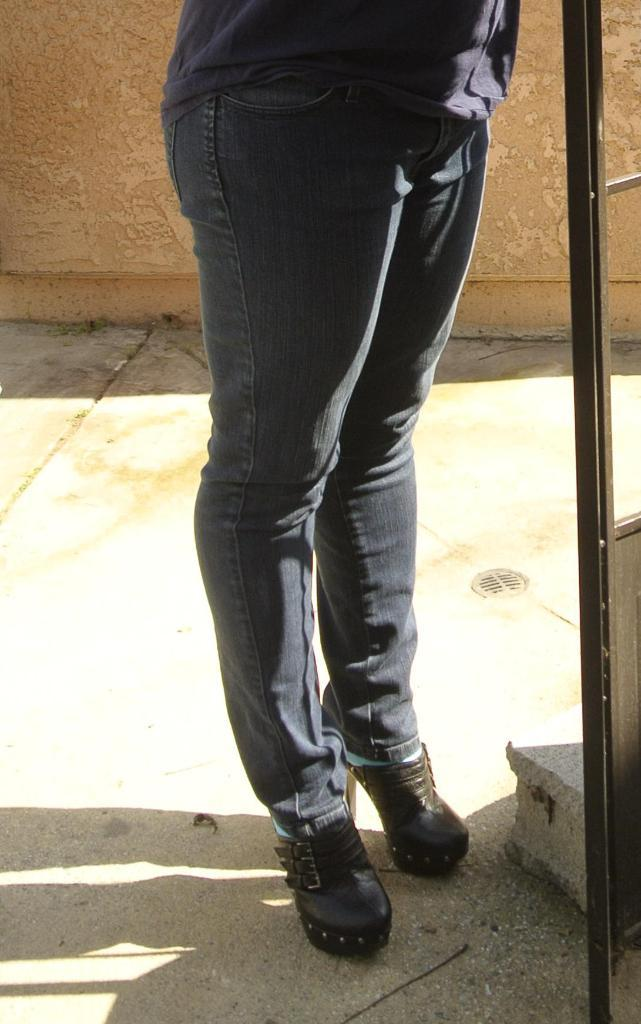What is the person in the image doing? The person is standing on the path in the image. What object is located on the right side of the person? There is an iron rod on the right side of the person. What is behind the person in the image? There is a wall behind the person. What type of trousers is the expert wearing in the image? There is no expert or trousers mentioned in the image; it only shows a person standing on a path with an iron rod on the right side and a wall behind them. 